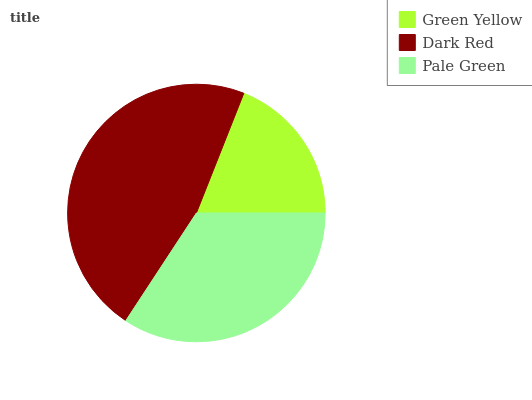Is Green Yellow the minimum?
Answer yes or no. Yes. Is Dark Red the maximum?
Answer yes or no. Yes. Is Pale Green the minimum?
Answer yes or no. No. Is Pale Green the maximum?
Answer yes or no. No. Is Dark Red greater than Pale Green?
Answer yes or no. Yes. Is Pale Green less than Dark Red?
Answer yes or no. Yes. Is Pale Green greater than Dark Red?
Answer yes or no. No. Is Dark Red less than Pale Green?
Answer yes or no. No. Is Pale Green the high median?
Answer yes or no. Yes. Is Pale Green the low median?
Answer yes or no. Yes. Is Green Yellow the high median?
Answer yes or no. No. Is Green Yellow the low median?
Answer yes or no. No. 